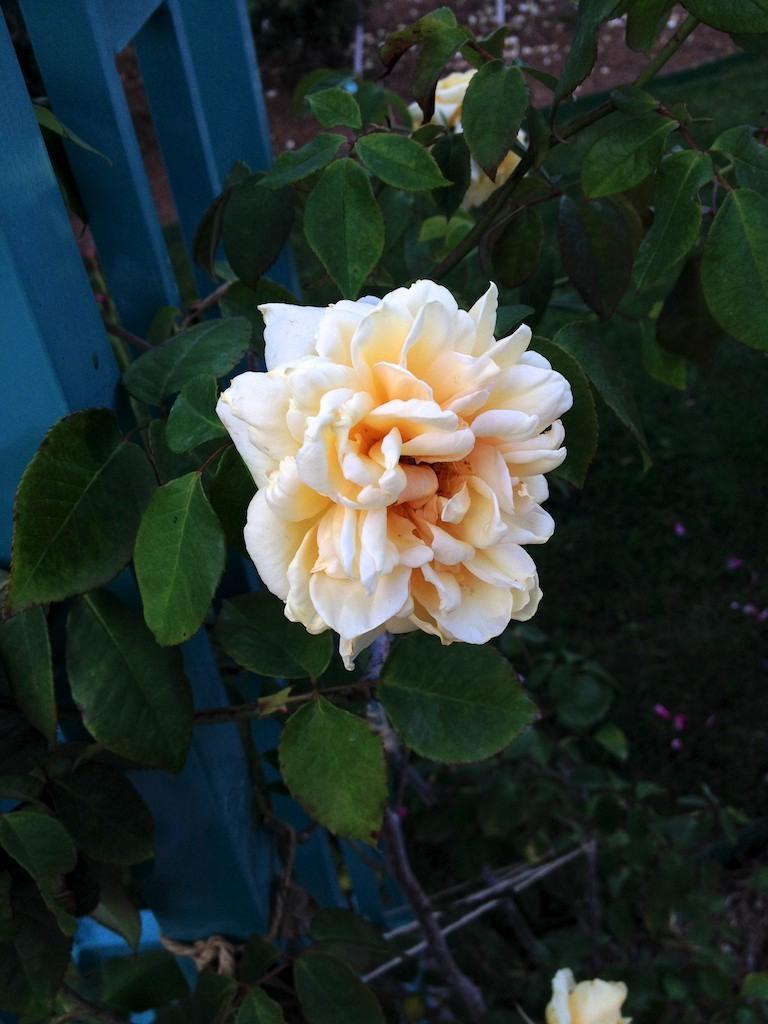In one or two sentences, can you explain what this image depicts? In this picture we can see few flowers and plants. 